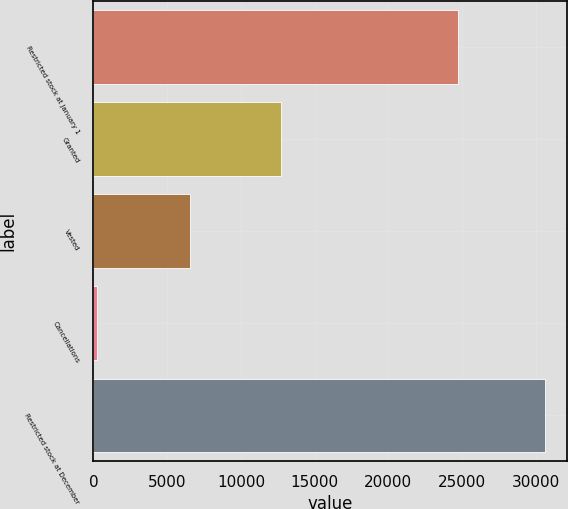Convert chart to OTSL. <chart><loc_0><loc_0><loc_500><loc_500><bar_chart><fcel>Restricted stock at January 1<fcel>Granted<fcel>Vested<fcel>Cancellations<fcel>Restricted stock at December<nl><fcel>24718<fcel>12693<fcel>6563<fcel>248<fcel>30600<nl></chart> 